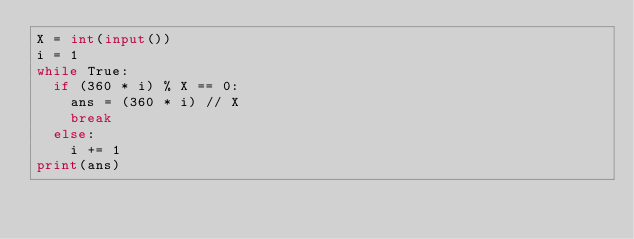<code> <loc_0><loc_0><loc_500><loc_500><_Python_>X = int(input())
i = 1
while True:
  if (360 * i) % X == 0:
    ans = (360 * i) // X
    break
  else:
    i += 1
print(ans)</code> 